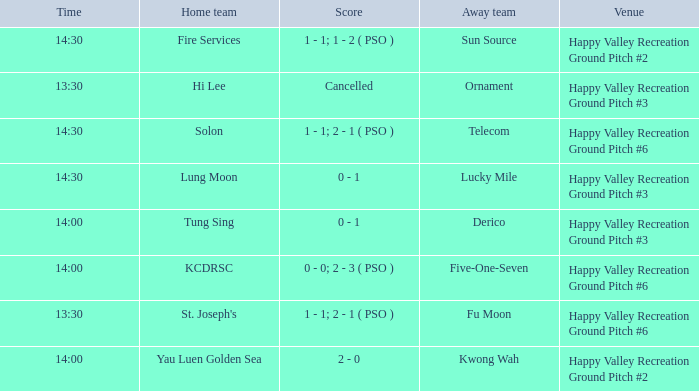What is the away team when solon was the home team? Telecom. 